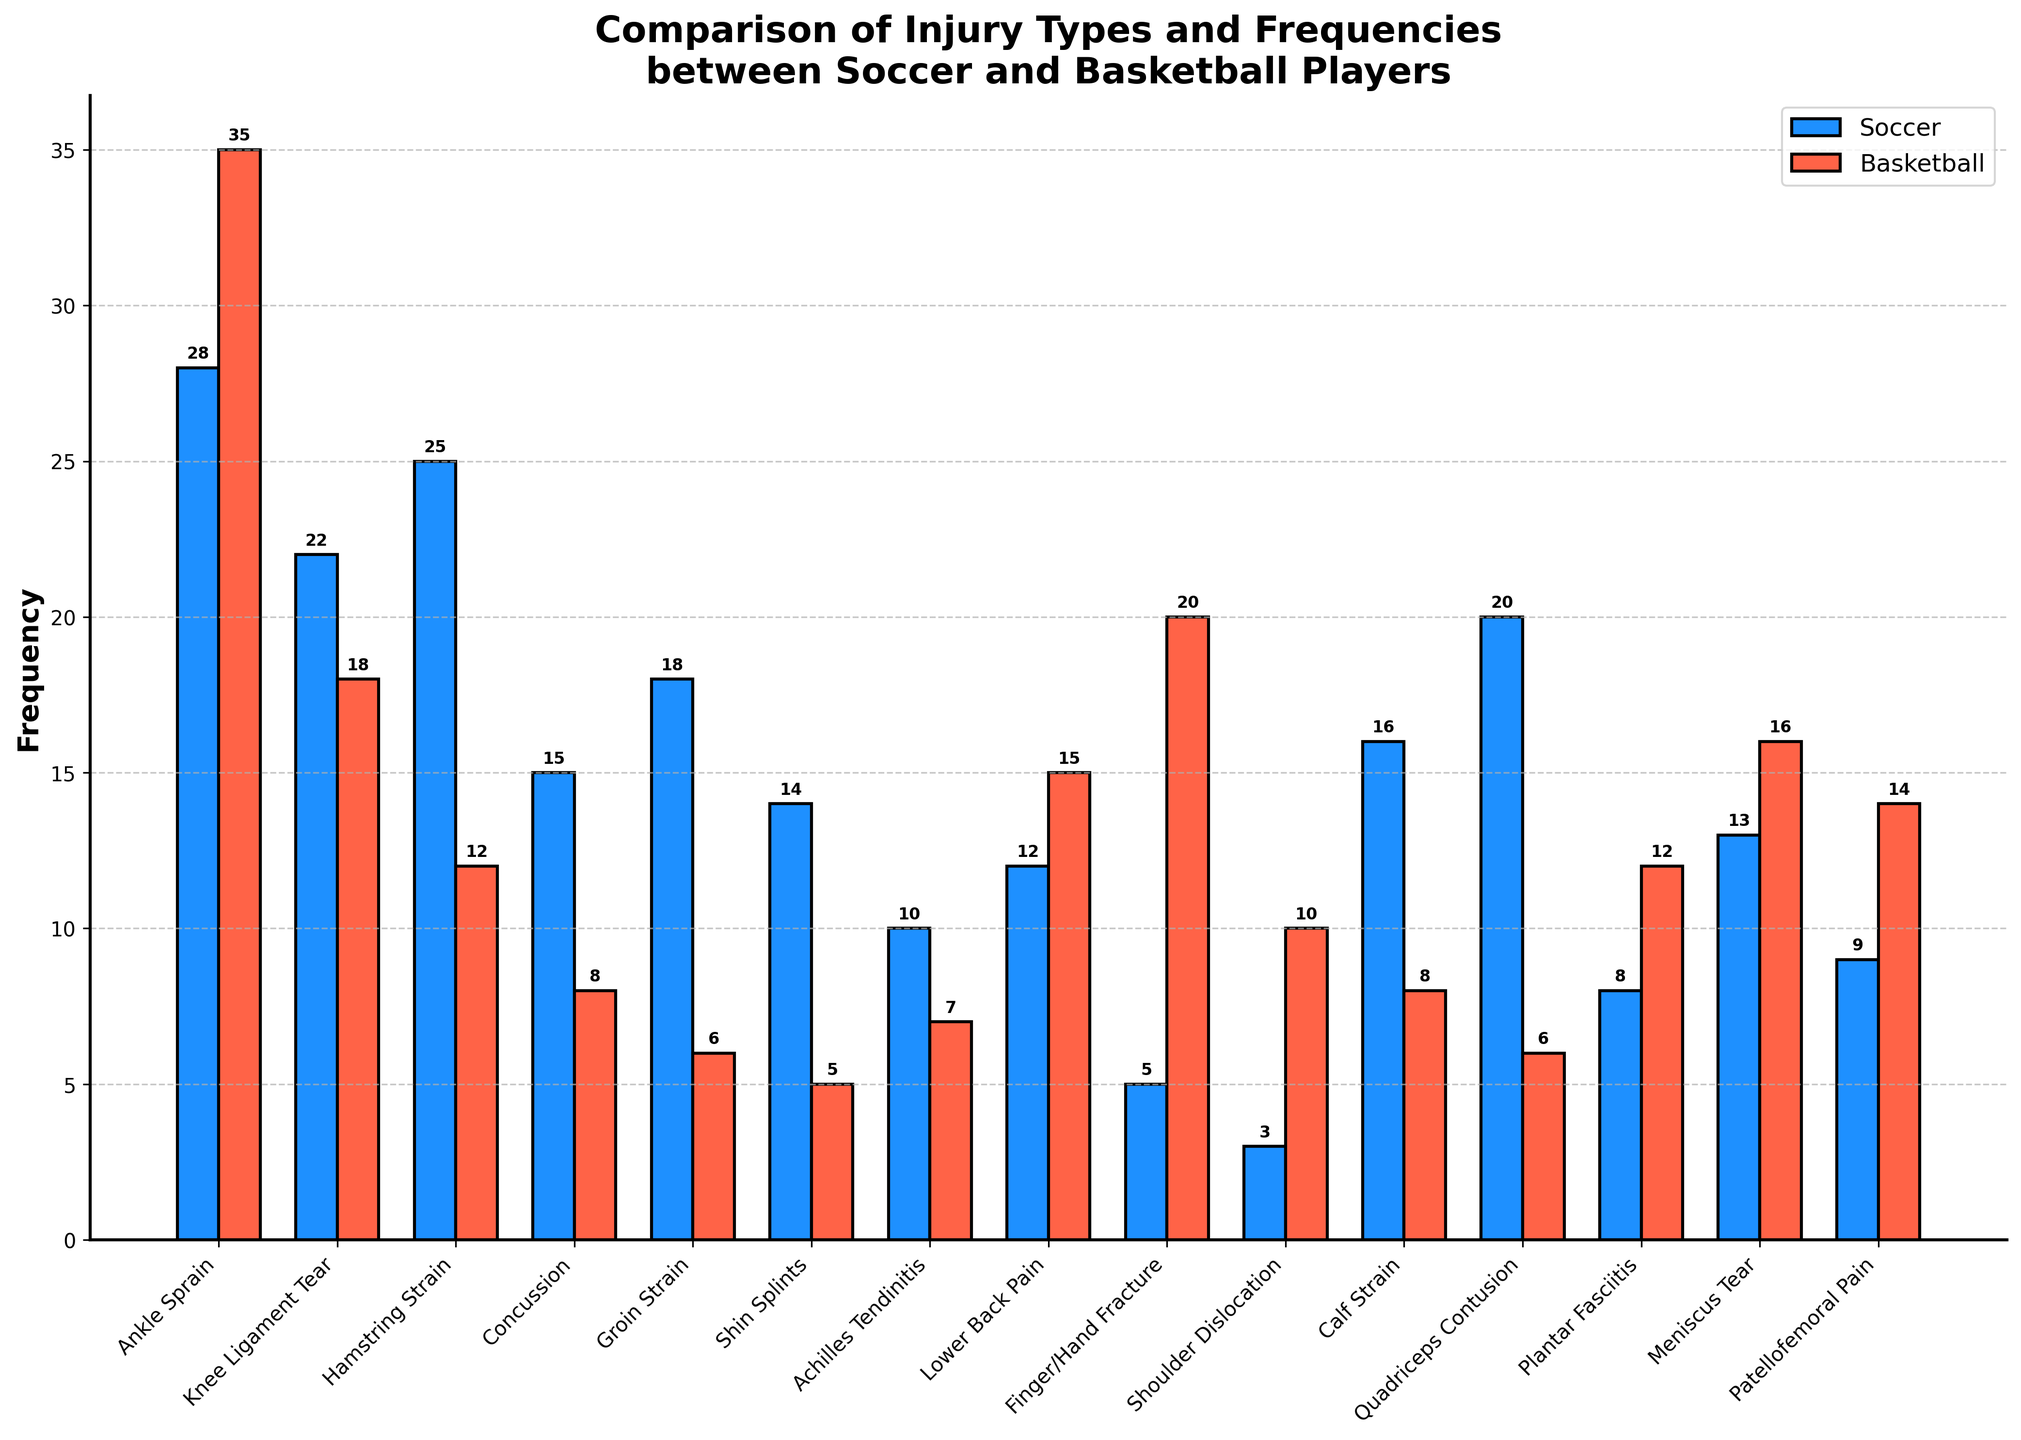What is the most common injury for soccer players? By observing the height of the bars for each injury type in soccer, the highest bar represents the most common injury. The 'Ankle Sprain' has the tallest bar with a value of 28, indicating it is the most common injury.
Answer: Ankle Sprain Which injury type has the biggest difference in frequency between soccer and basketball players? To identify the biggest difference, subtract the frequency of each injury type between the two sports. The largest difference observed here is for 'Ankle Sprain,' where the difference is 35 (basketball) - 28 (soccer) = 7.
Answer: Ankle Sprain Of the injuries listed, which sport has more injuries overall? Add the frequencies of all injuries for each sport. The total for soccer is 215 and the total for basketball is 192. By comparing these totals, it’s clear soccer has more injuries overall.
Answer: Soccer How does the frequency of concussions compare between the two sports? By looking at the height of the bars for 'Concussion,' one can observe that soccer players have 15 cases while basketball players have 8 cases. Thus, soccer players have more concussions.
Answer: Soccer Which injury is more frequent in basketball than in soccer? Look for bars where the height for basketball is greater than soccer. 'Finger/Hand Fracture' (20 vs. 5), 'Lower Back Pain' (15 vs. 12), 'Shoulder Dislocation' (10 vs. 3), 'Plantar Fasciitis' (12 vs. 8), 'Meniscus Tear' (16 vs. 13), and 'Patellofemoral Pain' (14 vs. 9) fit this criteria.
Answer: Finger/Hand Fracture, Lower Back Pain, Shoulder Dislocation, Plantar Fasciitis, Meniscus Tear, Patellofemoral Pain Which sport has a higher frequency of Achilles Tendinitis? Look at the heights of the 'Achilles Tendinitis' bars; soccer has a frequency of 10 while basketball has 7. Therefore, soccer has a higher frequency of Achilles Tendinitis.
Answer: Soccer If one player from each sport gets each type of injury once, what is the combined total for groin strains, shin splints, and calf strains for both sports? Add the frequencies for 'Groin Strain,' 'Shin Splints,' and 'Calf Strain' for both sports. The total is (18 + 6) + (14 + 5) + (16 + 8) = 67.
Answer: 67 What is the average frequency of knee ligament tears and quadriceps contusions for soccer players? Add the frequencies of 'Knee Ligament Tear' (22) and 'Quadriceps Contusion' (20), then divide by the number of injury types (2). (22 + 20) / 2 = 21.
Answer: 21 What is the least common injury for basketball players? Look for the bar with the smallest height for basketball. 'Shin Splints' has the shortest bar with a value of 5, indicating it is the least common injury.
Answer: Shin Splints 